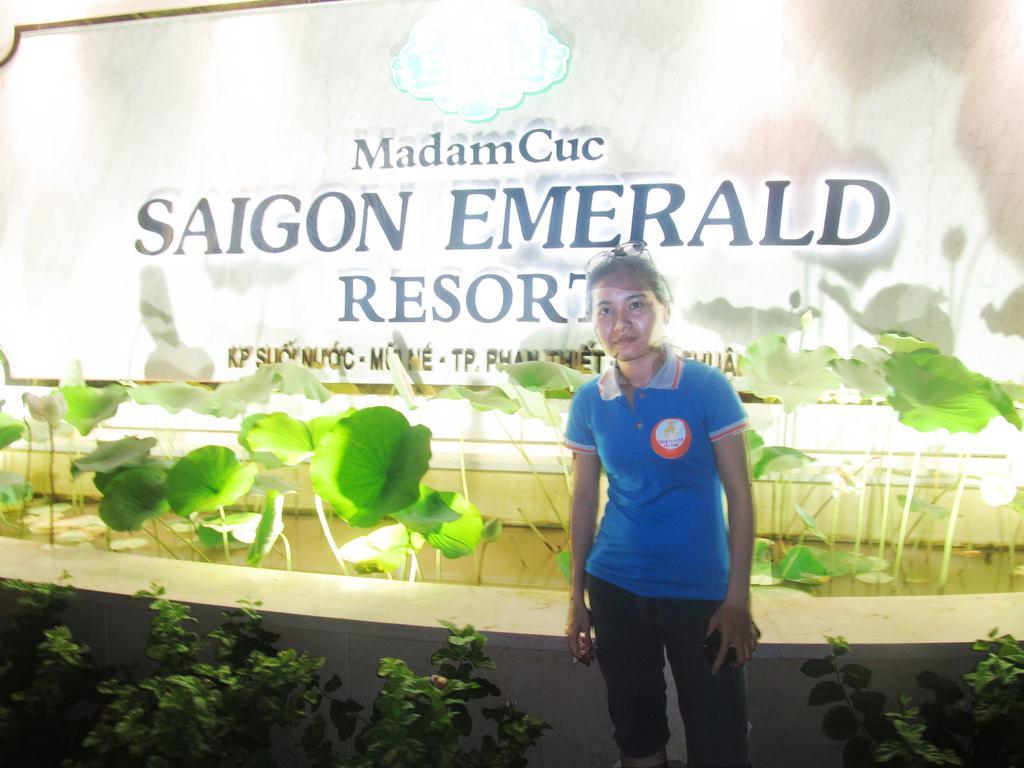Can you describe this image briefly? In the picture I can see a woman is standing and wearing blue color t-shirt. In the background I can see planets, something written on a board and some other objects. 